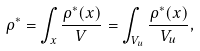Convert formula to latex. <formula><loc_0><loc_0><loc_500><loc_500>\rho ^ { * } = \int _ { x } \frac { \rho ^ { * } ( { x } ) } { V } = \int _ { V _ { u } } \frac { \rho ^ { * } ( { x } ) } { V _ { u } } ,</formula> 